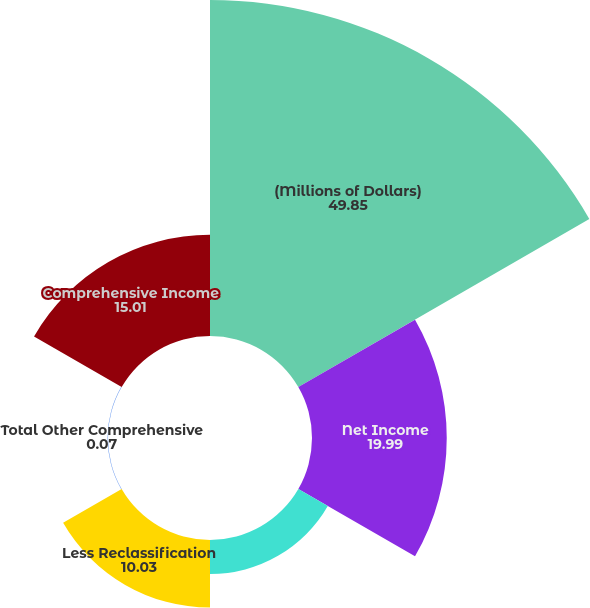Convert chart to OTSL. <chart><loc_0><loc_0><loc_500><loc_500><pie_chart><fcel>(Millions of Dollars)<fcel>Net Income<fcel>Unrealized gains on<fcel>Less Reclassification<fcel>Total Other Comprehensive<fcel>Comprehensive Income<nl><fcel>49.85%<fcel>19.99%<fcel>5.05%<fcel>10.03%<fcel>0.07%<fcel>15.01%<nl></chart> 